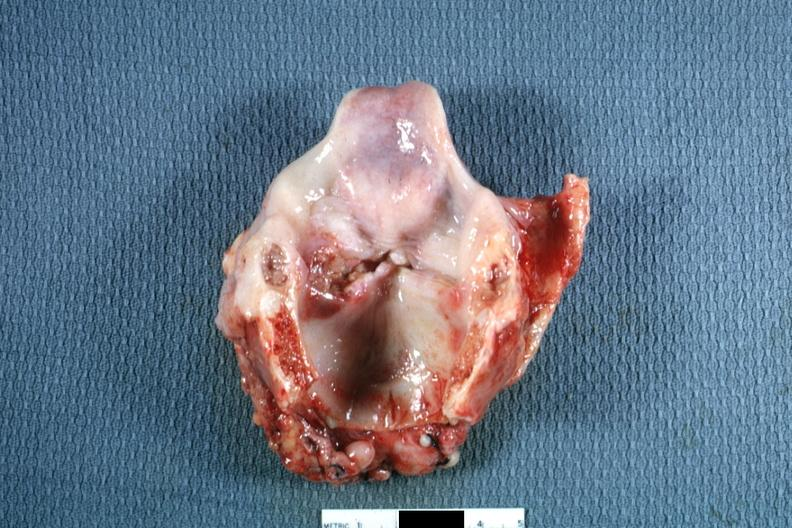what does this image show?
Answer the question using a single word or phrase. Ulcerative lesion left true cord quite good 